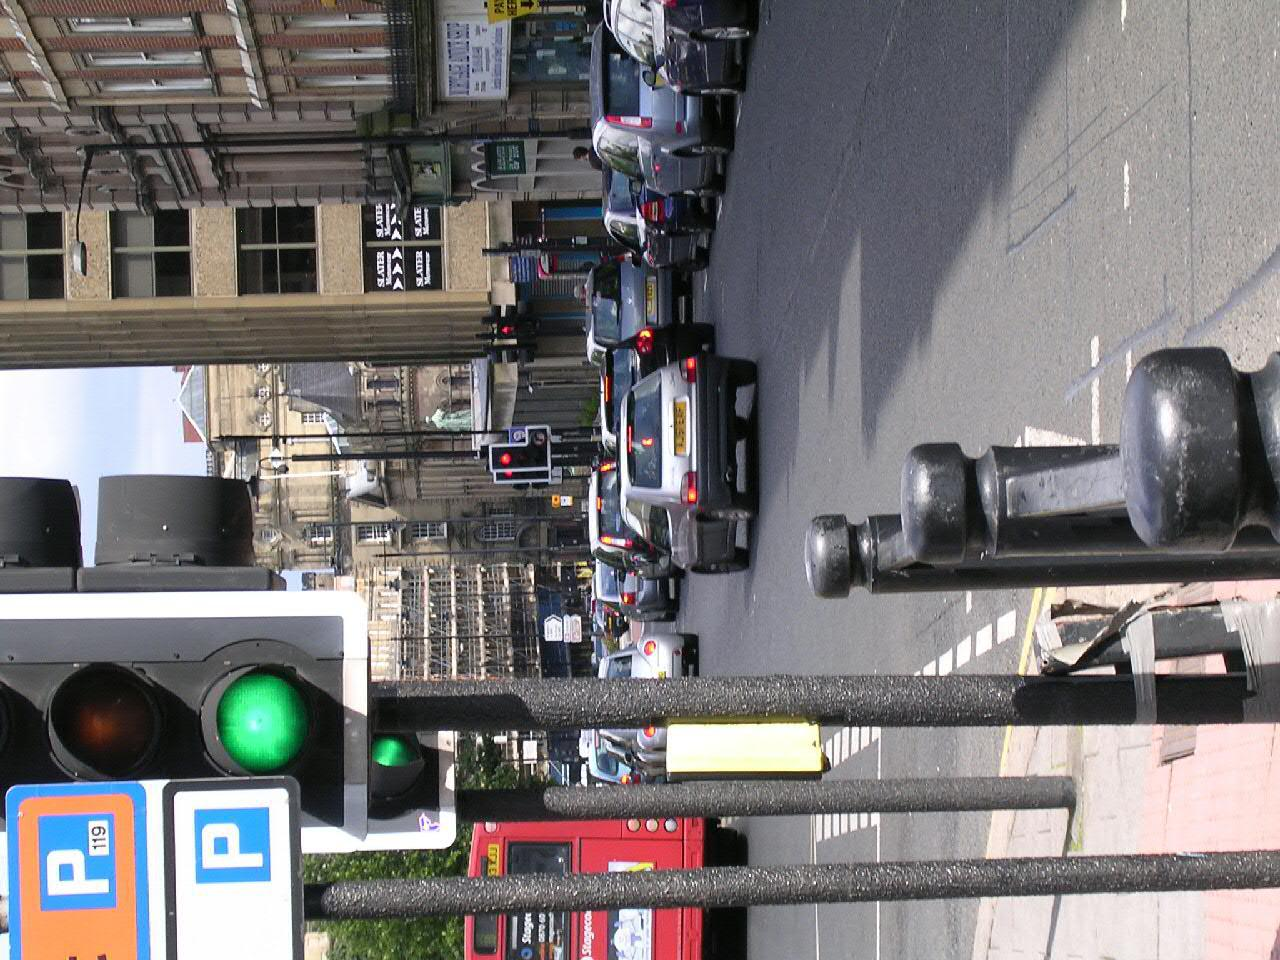Question: what color is the bus on the left?
Choices:
A. Green.
B. Blue.
C. Black.
D. Red.
Answer with the letter. Answer: D Question: what is the weather?
Choices:
A. Foggy and Sultry.
B. Sunny and clear.
C. Wet and Cold.
D. Rainy and windy.
Answer with the letter. Answer: B Question: where is the red bus?
Choices:
A. On the right.
B. In front of you.
C. Behind you.
D. On the left.
Answer with the letter. Answer: D Question: why are the cars stopped?
Choices:
A. They are at a red light.
B. Cops pulled them over.
C. They are at a stop sign.
D. There is a traffic jam.
Answer with the letter. Answer: A Question: where are the cars?
Choices:
A. In the garage.
B. On the road.
C. In the parking lot.
D. At the junk yard.
Answer with the letter. Answer: B Question: how many buildings can you see?
Choices:
A. Four.
B. None.
C. Five.
D. Three.
Answer with the letter. Answer: C Question: what are parked along the right side of the street?
Choices:
A. Trucks.
B. Cars.
C. Lorry.
D. Scooters.
Answer with the letter. Answer: B Question: what color is the stop light to the right?
Choices:
A. Red.
B. Yellow.
C. Green.
D. Orange.
Answer with the letter. Answer: C Question: what color is the stoplight in the distance?
Choices:
A. Green.
B. Orange.
C. Yellow.
D. Red.
Answer with the letter. Answer: D Question: what are casting the shadows covering part of the street?
Choices:
A. Trees.
B. Posts.
C. Light poles.
D. Buildings.
Answer with the letter. Answer: D Question: what is in foreground?
Choices:
A. A bridge outline with a ship in the harbor.
B. Cityscape with traffic and stop light.
C. A monument with tourists.
D. A shopping mall outline with shoppers.
Answer with the letter. Answer: B Question: what is in leftmost lane?
Choices:
A. Black vehicle.
B. Green vehicle.
C. Red vehicle.
D. Blue vehicle.
Answer with the letter. Answer: C Question: where is orange sign?
Choices:
A. Under the yellow light.
B. On top of the red traffic light.
C. Next to green traffic light.
D. In between the green and yellow light.
Answer with the letter. Answer: C Question: what color are three of the traffic lights on right side of street?
Choices:
A. Yellow.
B. Orange.
C. White.
D. Red.
Answer with the letter. Answer: D Question: what kind of street is this?
Choices:
A. Paved.
B. A city street.
C. A dirt road.
D. A highway.
Answer with the letter. Answer: B Question: what color are most of the license plates on the cars?
Choices:
A. White.
B. Black.
C. Yellow.
D. Blue.
Answer with the letter. Answer: C Question: what color is the license plate?
Choices:
A. Blue.
B. Yellow.
C. Brown.
D. White.
Answer with the letter. Answer: B Question: what is wrong with the image?
Choices:
A. Backwards.
B. Blurry.
C. Sideways.
D. Upside down.
Answer with the letter. Answer: C Question: what color are the lines on the street?
Choices:
A. Brown.
B. Black.
C. Yellow.
D. White.
Answer with the letter. Answer: D Question: what color is the bus?
Choices:
A. Yellow.
B. Blue.
C. Red.
D. Orange.
Answer with the letter. Answer: C 